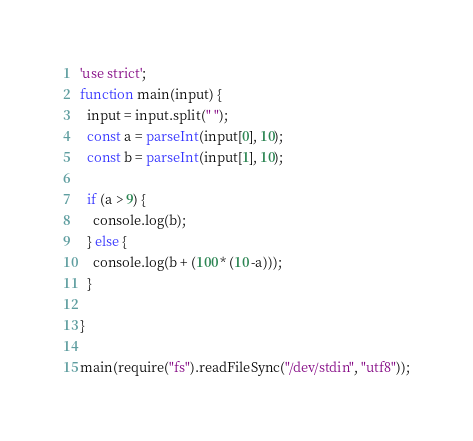<code> <loc_0><loc_0><loc_500><loc_500><_JavaScript_>'use strict';
function main(input) {
  input = input.split(" ");
  const a = parseInt(input[0], 10);
  const b = parseInt(input[1], 10);

  if (a > 9) {
    console.log(b);
  } else {
    console.log(b + (100 * (10 -a)));
  }
  
}

main(require("fs").readFileSync("/dev/stdin", "utf8"));</code> 